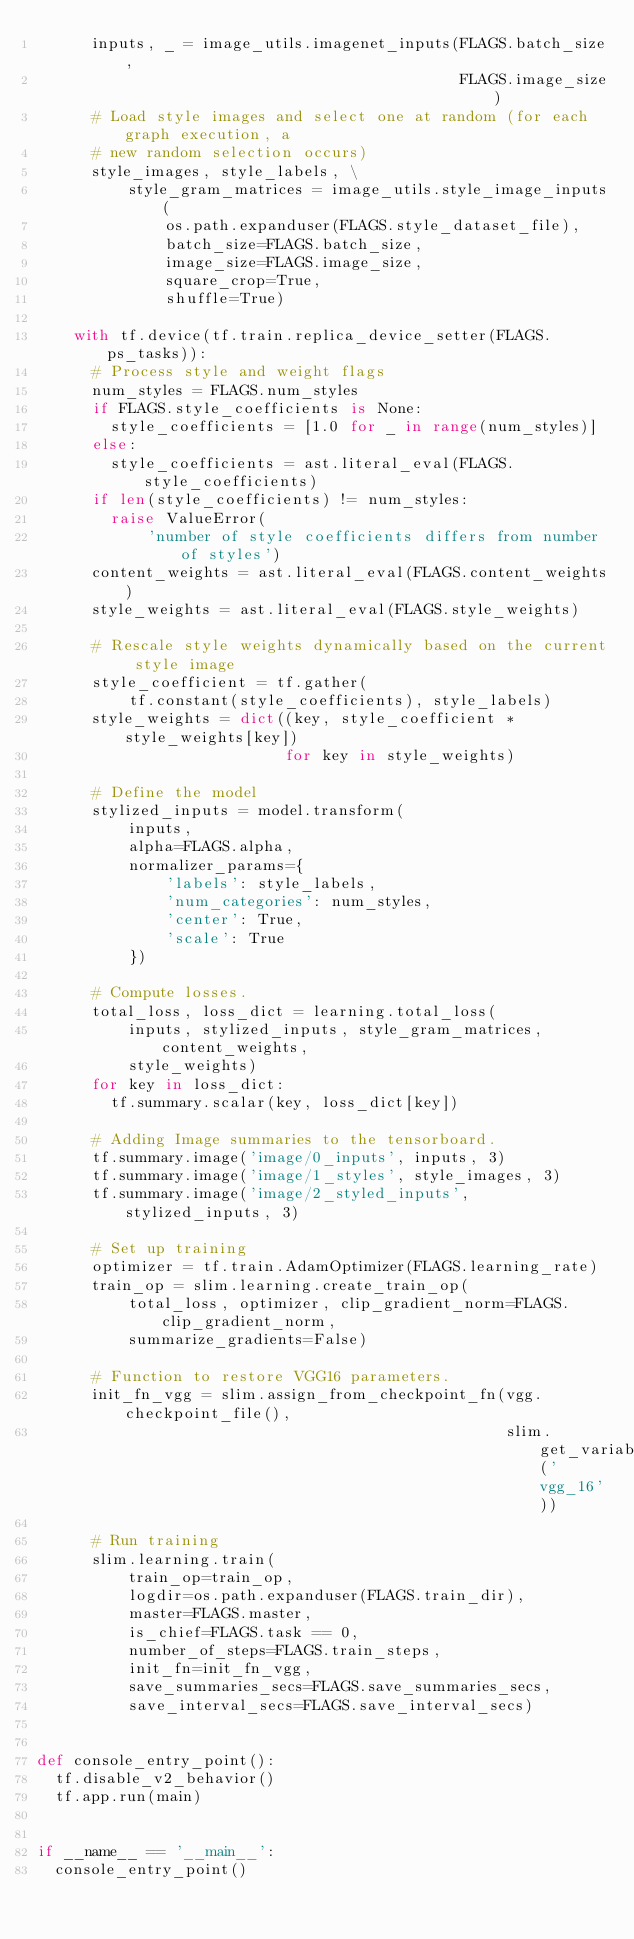<code> <loc_0><loc_0><loc_500><loc_500><_Python_>      inputs, _ = image_utils.imagenet_inputs(FLAGS.batch_size,
                                              FLAGS.image_size)
      # Load style images and select one at random (for each graph execution, a
      # new random selection occurs)
      style_images, style_labels, \
          style_gram_matrices = image_utils.style_image_inputs(
              os.path.expanduser(FLAGS.style_dataset_file),
              batch_size=FLAGS.batch_size,
              image_size=FLAGS.image_size,
              square_crop=True,
              shuffle=True)

    with tf.device(tf.train.replica_device_setter(FLAGS.ps_tasks)):
      # Process style and weight flags
      num_styles = FLAGS.num_styles
      if FLAGS.style_coefficients is None:
        style_coefficients = [1.0 for _ in range(num_styles)]
      else:
        style_coefficients = ast.literal_eval(FLAGS.style_coefficients)
      if len(style_coefficients) != num_styles:
        raise ValueError(
            'number of style coefficients differs from number of styles')
      content_weights = ast.literal_eval(FLAGS.content_weights)
      style_weights = ast.literal_eval(FLAGS.style_weights)

      # Rescale style weights dynamically based on the current style image
      style_coefficient = tf.gather(
          tf.constant(style_coefficients), style_labels)
      style_weights = dict((key, style_coefficient * style_weights[key])
                           for key in style_weights)

      # Define the model
      stylized_inputs = model.transform(
          inputs,
          alpha=FLAGS.alpha,
          normalizer_params={
              'labels': style_labels,
              'num_categories': num_styles,
              'center': True,
              'scale': True
          })

      # Compute losses.
      total_loss, loss_dict = learning.total_loss(
          inputs, stylized_inputs, style_gram_matrices, content_weights,
          style_weights)
      for key in loss_dict:
        tf.summary.scalar(key, loss_dict[key])

      # Adding Image summaries to the tensorboard.
      tf.summary.image('image/0_inputs', inputs, 3)
      tf.summary.image('image/1_styles', style_images, 3)
      tf.summary.image('image/2_styled_inputs', stylized_inputs, 3)

      # Set up training
      optimizer = tf.train.AdamOptimizer(FLAGS.learning_rate)
      train_op = slim.learning.create_train_op(
          total_loss, optimizer, clip_gradient_norm=FLAGS.clip_gradient_norm,
          summarize_gradients=False)

      # Function to restore VGG16 parameters.
      init_fn_vgg = slim.assign_from_checkpoint_fn(vgg.checkpoint_file(),
                                                   slim.get_variables('vgg_16'))

      # Run training
      slim.learning.train(
          train_op=train_op,
          logdir=os.path.expanduser(FLAGS.train_dir),
          master=FLAGS.master,
          is_chief=FLAGS.task == 0,
          number_of_steps=FLAGS.train_steps,
          init_fn=init_fn_vgg,
          save_summaries_secs=FLAGS.save_summaries_secs,
          save_interval_secs=FLAGS.save_interval_secs)


def console_entry_point():
  tf.disable_v2_behavior()
  tf.app.run(main)


if __name__ == '__main__':
  console_entry_point()
</code> 